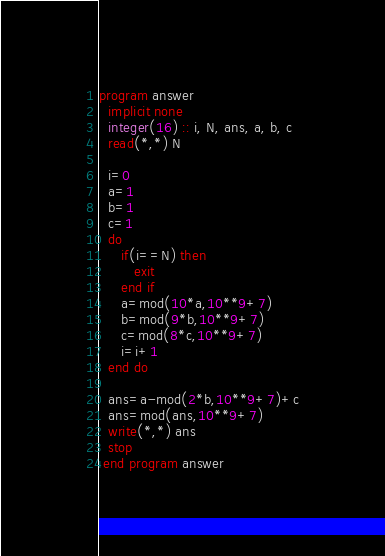Convert code to text. <code><loc_0><loc_0><loc_500><loc_500><_FORTRAN_>program answer
  implicit none
  integer(16) :: i, N, ans, a, b, c
  read(*,*) N

  i=0
  a=1
  b=1
  c=1
  do
     if(i==N) then
        exit
     end if
     a=mod(10*a,10**9+7)
     b=mod(9*b,10**9+7)
     c=mod(8*c,10**9+7)
     i=i+1
  end do

  ans=a-mod(2*b,10**9+7)+c
  ans=mod(ans,10**9+7)
  write(*,*) ans
  stop
 end program answer</code> 